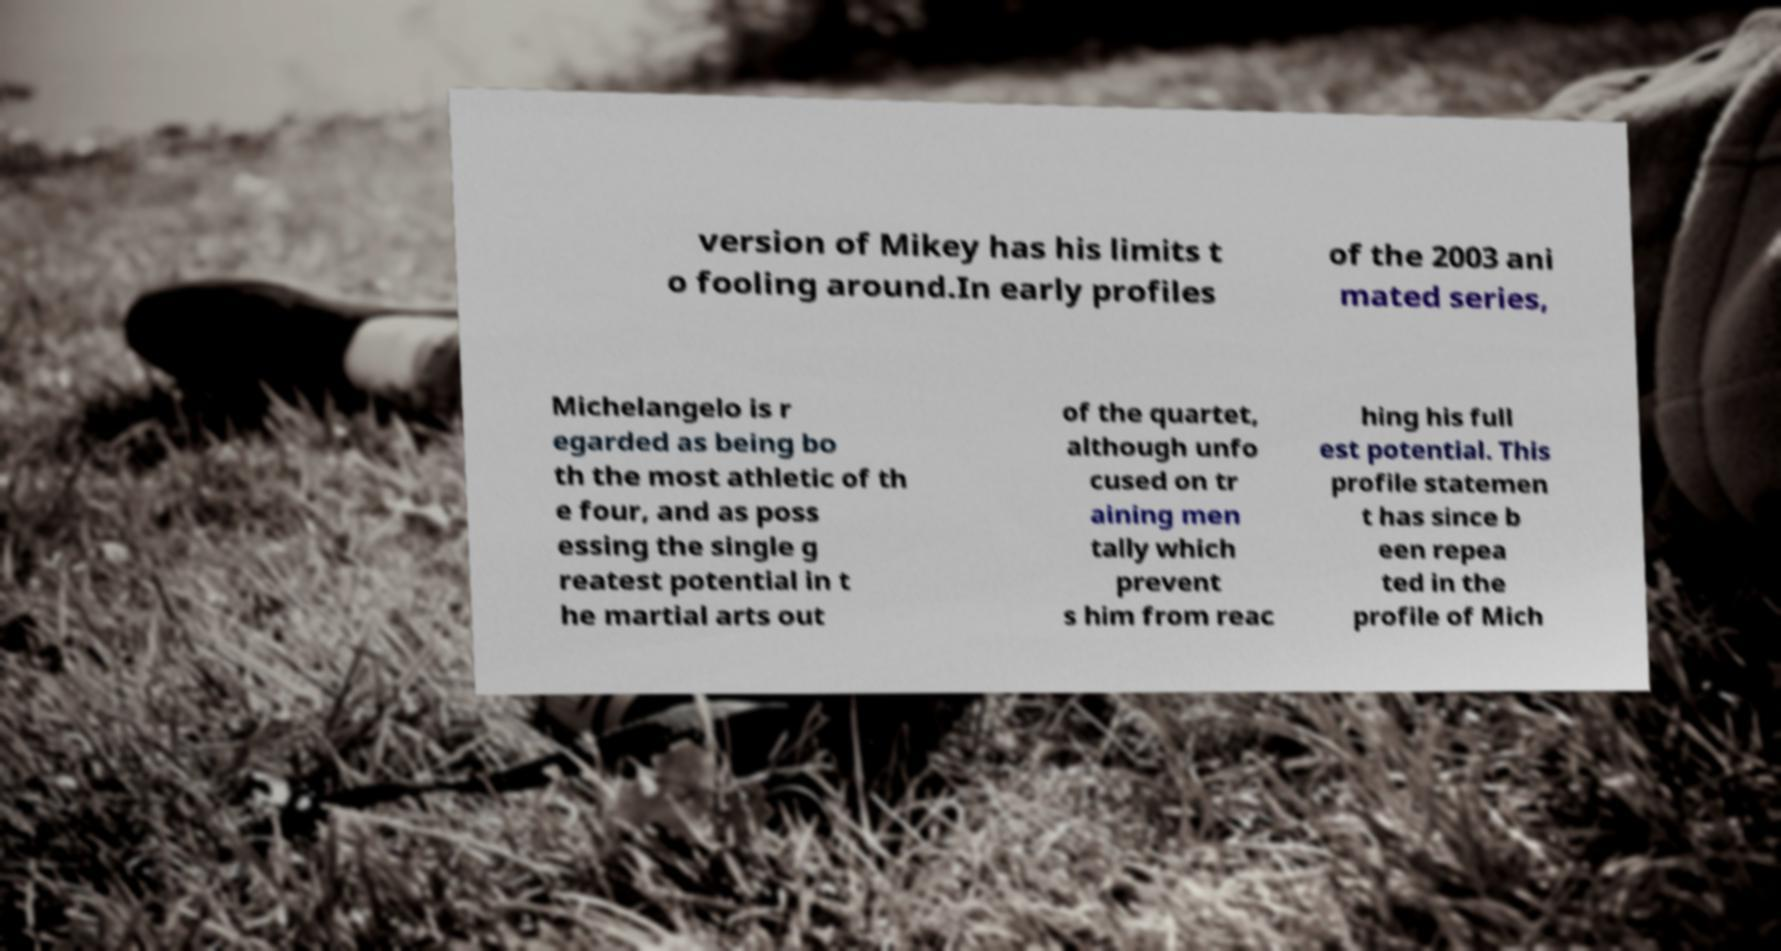Could you assist in decoding the text presented in this image and type it out clearly? version of Mikey has his limits t o fooling around.In early profiles of the 2003 ani mated series, Michelangelo is r egarded as being bo th the most athletic of th e four, and as poss essing the single g reatest potential in t he martial arts out of the quartet, although unfo cused on tr aining men tally which prevent s him from reac hing his full est potential. This profile statemen t has since b een repea ted in the profile of Mich 